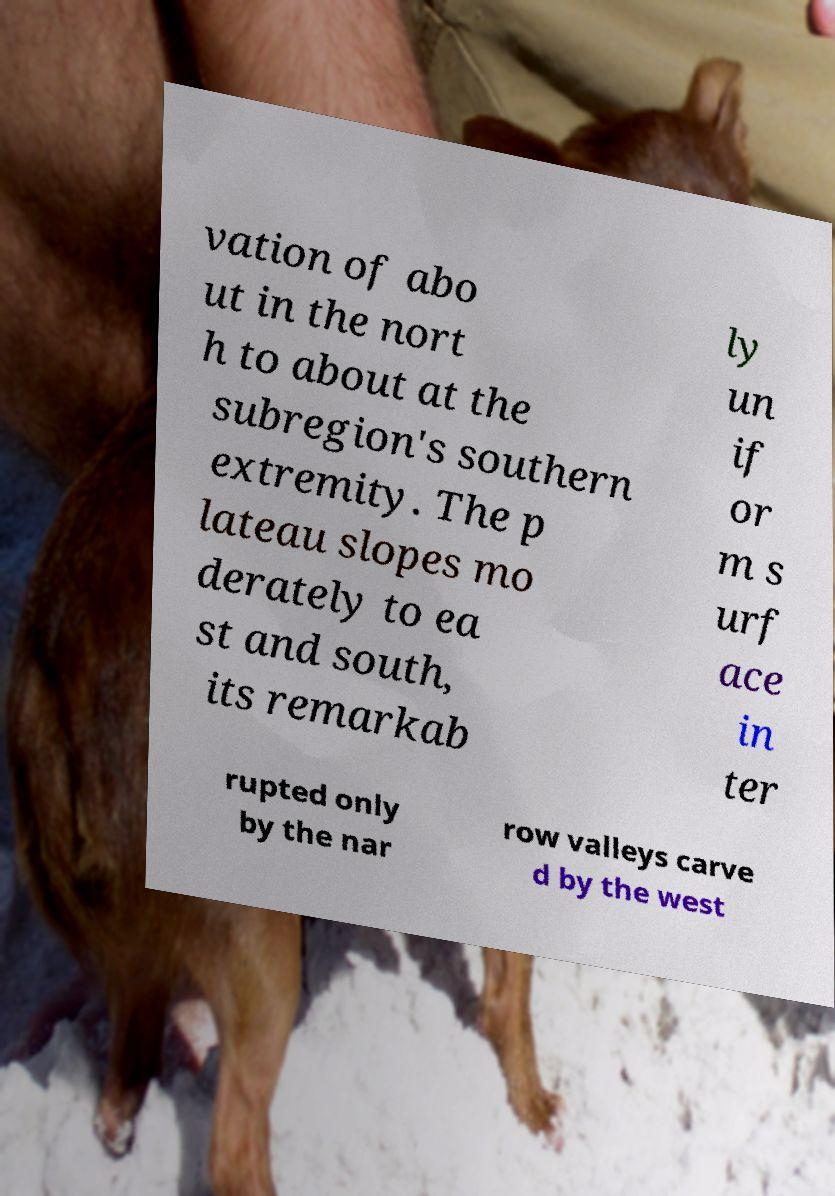I need the written content from this picture converted into text. Can you do that? vation of abo ut in the nort h to about at the subregion's southern extremity. The p lateau slopes mo derately to ea st and south, its remarkab ly un if or m s urf ace in ter rupted only by the nar row valleys carve d by the west 